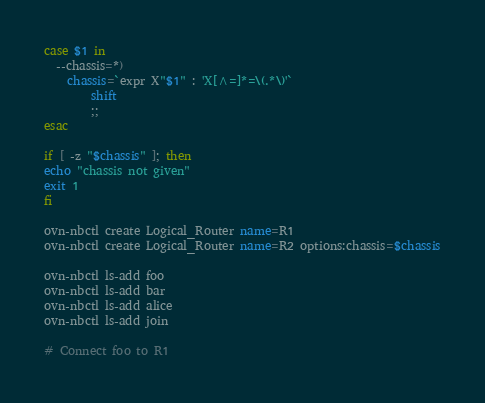<code> <loc_0><loc_0><loc_500><loc_500><_Bash_>case $1 in
  --chassis=*)
    chassis=`expr X"$1" : 'X[^=]*=\(.*\)'`
        shift
        ;;
esac

if [ -z "$chassis" ]; then
echo "chassis not given"
exit 1
fi

ovn-nbctl create Logical_Router name=R1
ovn-nbctl create Logical_Router name=R2 options:chassis=$chassis

ovn-nbctl ls-add foo
ovn-nbctl ls-add bar
ovn-nbctl ls-add alice
ovn-nbctl ls-add join

# Connect foo to R1</code> 